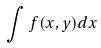Convert formula to latex. <formula><loc_0><loc_0><loc_500><loc_500>\int f ( x , y ) d x</formula> 